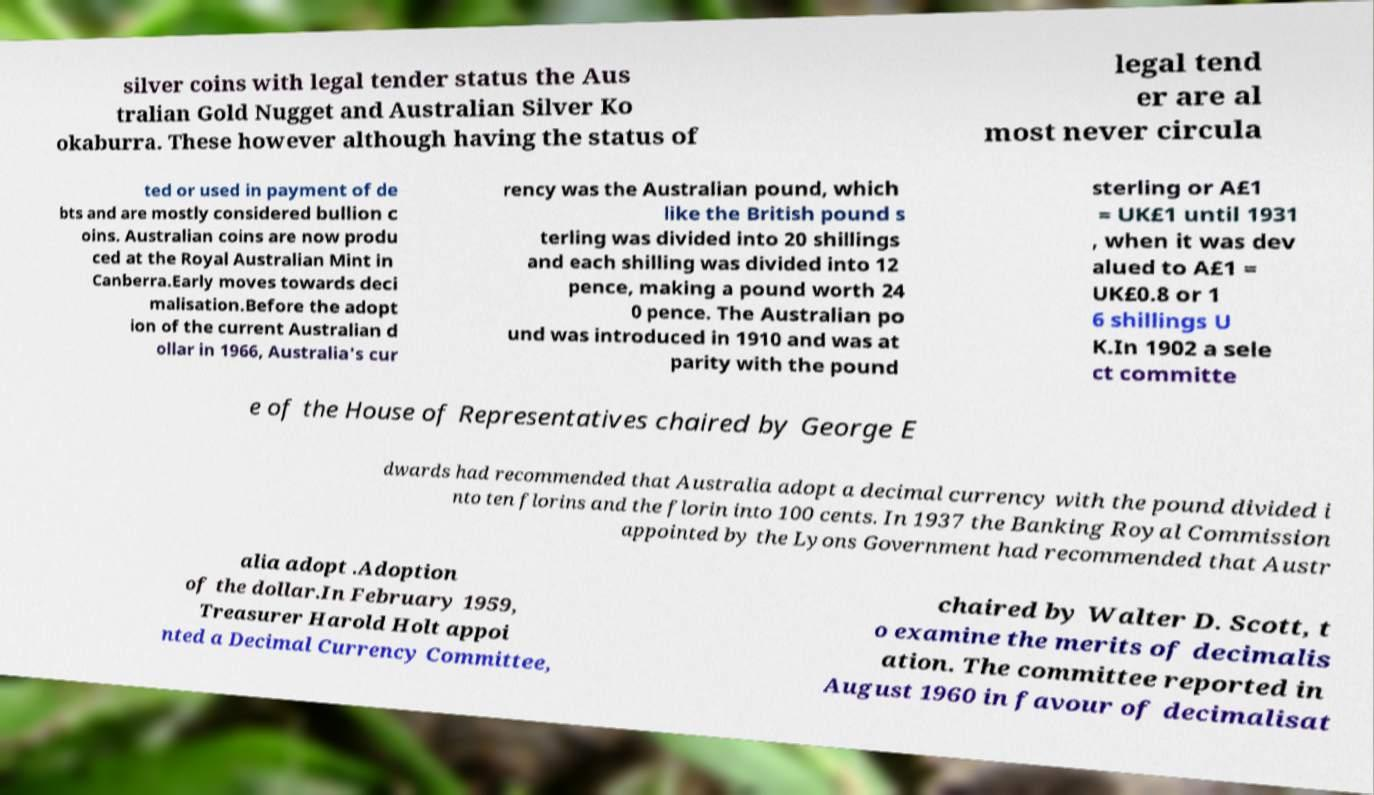Could you assist in decoding the text presented in this image and type it out clearly? silver coins with legal tender status the Aus tralian Gold Nugget and Australian Silver Ko okaburra. These however although having the status of legal tend er are al most never circula ted or used in payment of de bts and are mostly considered bullion c oins. Australian coins are now produ ced at the Royal Australian Mint in Canberra.Early moves towards deci malisation.Before the adopt ion of the current Australian d ollar in 1966, Australia's cur rency was the Australian pound, which like the British pound s terling was divided into 20 shillings and each shilling was divided into 12 pence, making a pound worth 24 0 pence. The Australian po und was introduced in 1910 and was at parity with the pound sterling or A£1 = UK£1 until 1931 , when it was dev alued to A£1 = UK£0.8 or 1 6 shillings U K.In 1902 a sele ct committe e of the House of Representatives chaired by George E dwards had recommended that Australia adopt a decimal currency with the pound divided i nto ten florins and the florin into 100 cents. In 1937 the Banking Royal Commission appointed by the Lyons Government had recommended that Austr alia adopt .Adoption of the dollar.In February 1959, Treasurer Harold Holt appoi nted a Decimal Currency Committee, chaired by Walter D. Scott, t o examine the merits of decimalis ation. The committee reported in August 1960 in favour of decimalisat 